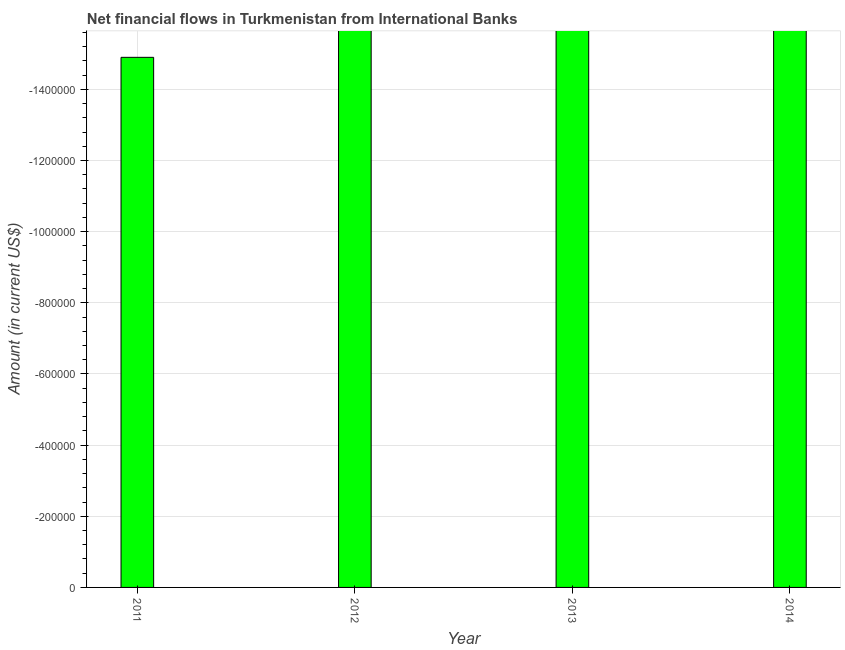Does the graph contain any zero values?
Offer a terse response. Yes. What is the title of the graph?
Your answer should be compact. Net financial flows in Turkmenistan from International Banks. What is the label or title of the X-axis?
Provide a succinct answer. Year. What is the label or title of the Y-axis?
Make the answer very short. Amount (in current US$). What is the net financial flows from ibrd in 2011?
Provide a succinct answer. 0. Across all years, what is the minimum net financial flows from ibrd?
Provide a short and direct response. 0. What is the sum of the net financial flows from ibrd?
Provide a succinct answer. 0. What is the average net financial flows from ibrd per year?
Offer a terse response. 0. How many bars are there?
Provide a succinct answer. 0. Are all the bars in the graph horizontal?
Your answer should be compact. No. How many years are there in the graph?
Ensure brevity in your answer.  4. What is the Amount (in current US$) in 2011?
Make the answer very short. 0. What is the Amount (in current US$) of 2013?
Give a very brief answer. 0. 